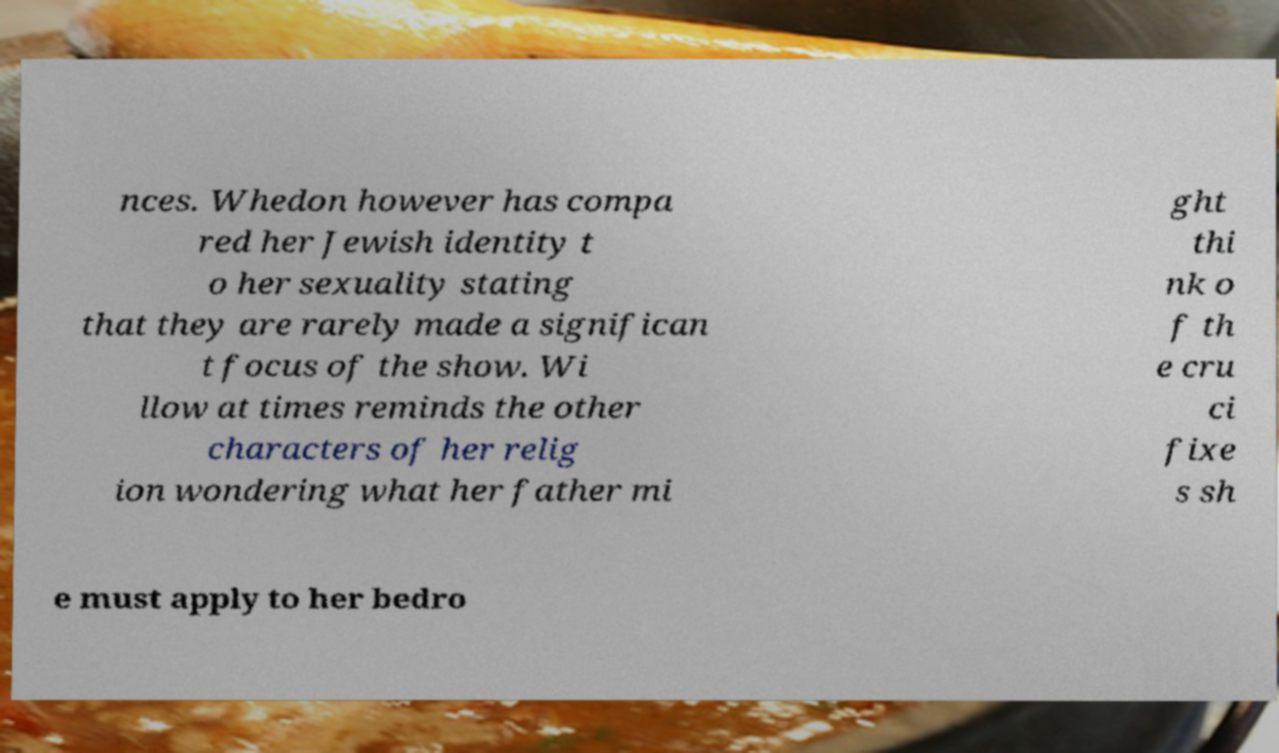What messages or text are displayed in this image? I need them in a readable, typed format. nces. Whedon however has compa red her Jewish identity t o her sexuality stating that they are rarely made a significan t focus of the show. Wi llow at times reminds the other characters of her relig ion wondering what her father mi ght thi nk o f th e cru ci fixe s sh e must apply to her bedro 